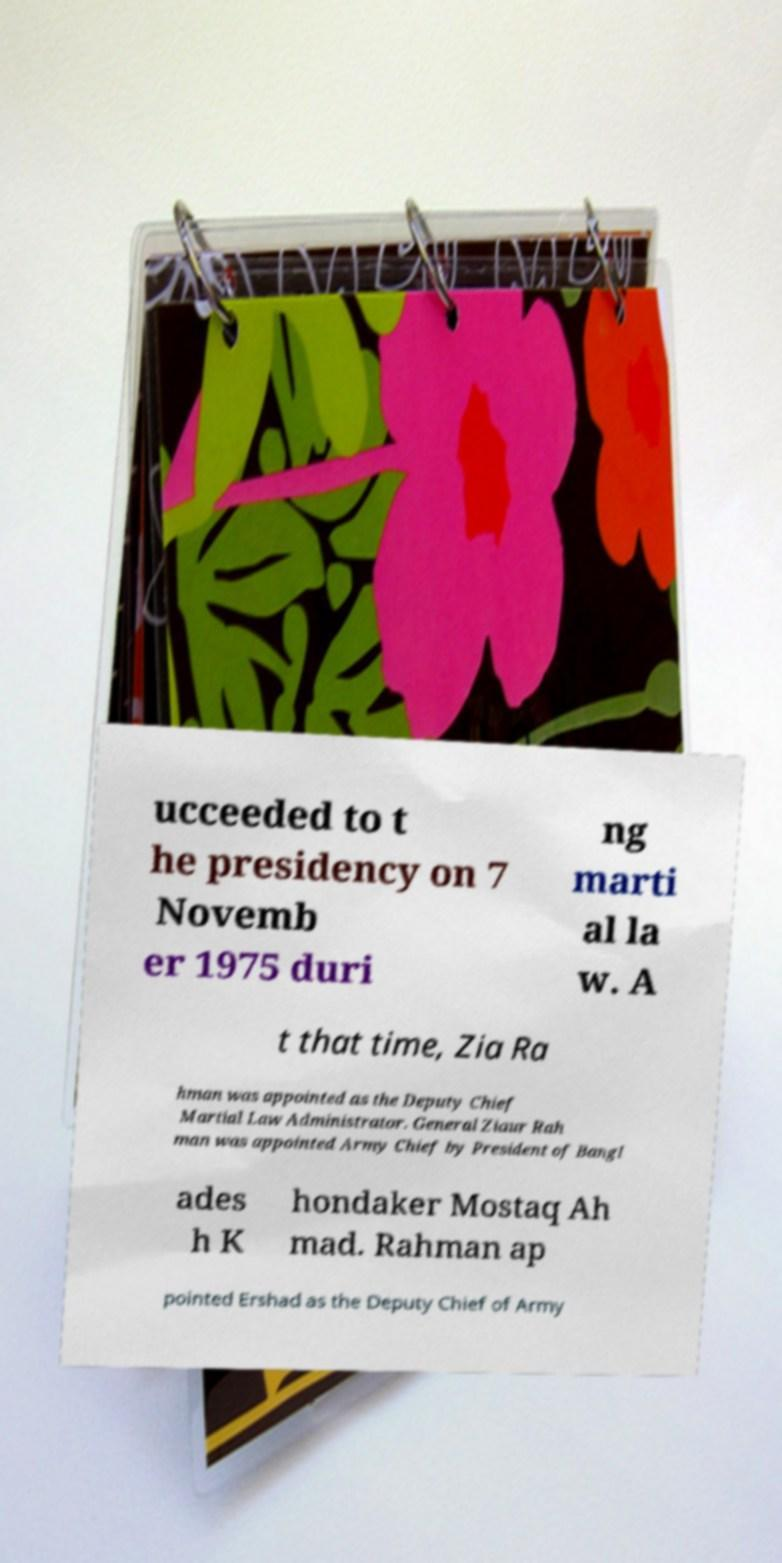What messages or text are displayed in this image? I need them in a readable, typed format. ucceeded to t he presidency on 7 Novemb er 1975 duri ng marti al la w. A t that time, Zia Ra hman was appointed as the Deputy Chief Martial Law Administrator. General Ziaur Rah man was appointed Army Chief by President of Bangl ades h K hondaker Mostaq Ah mad. Rahman ap pointed Ershad as the Deputy Chief of Army 